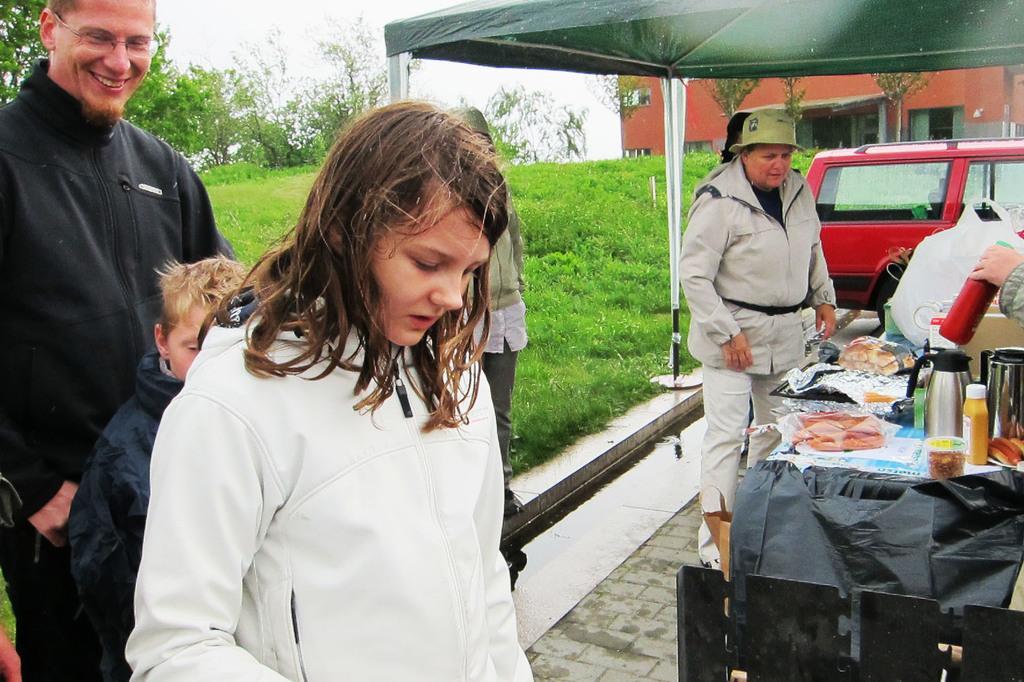Can you describe this image briefly? In this image, I can see few people standing. On the right side of the image, I can see a vehicle and a person's hand holding a bottle. There is a table with food items, kettle, bottle and few other objects on it. At the top of the image, I can see a tent. In the background, there are plants, trees, a building and the sky. 